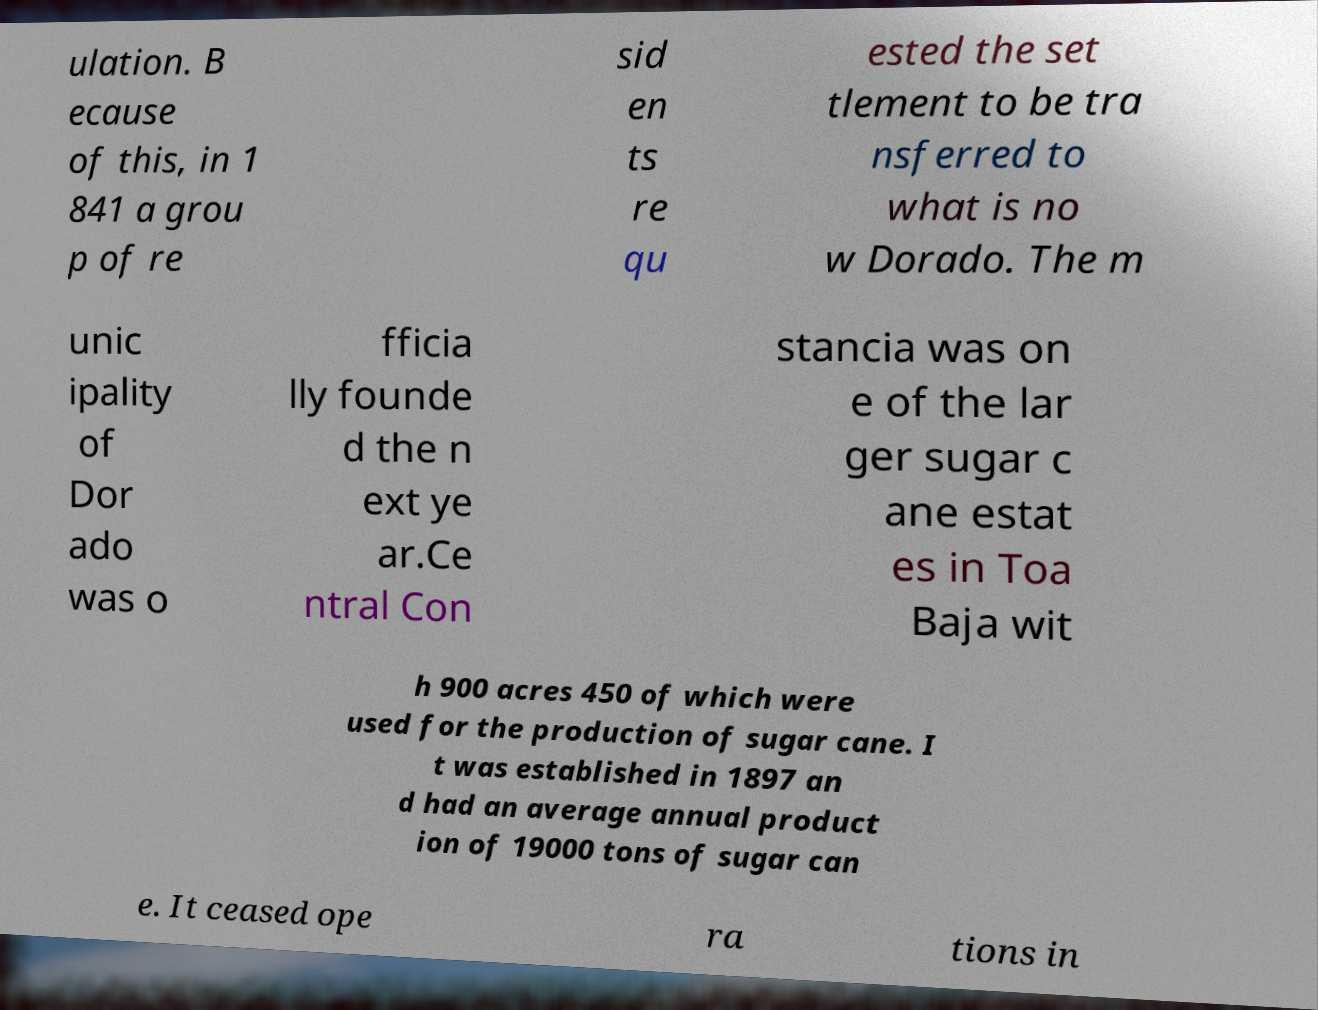For documentation purposes, I need the text within this image transcribed. Could you provide that? ulation. B ecause of this, in 1 841 a grou p of re sid en ts re qu ested the set tlement to be tra nsferred to what is no w Dorado. The m unic ipality of Dor ado was o fficia lly founde d the n ext ye ar.Ce ntral Con stancia was on e of the lar ger sugar c ane estat es in Toa Baja wit h 900 acres 450 of which were used for the production of sugar cane. I t was established in 1897 an d had an average annual product ion of 19000 tons of sugar can e. It ceased ope ra tions in 